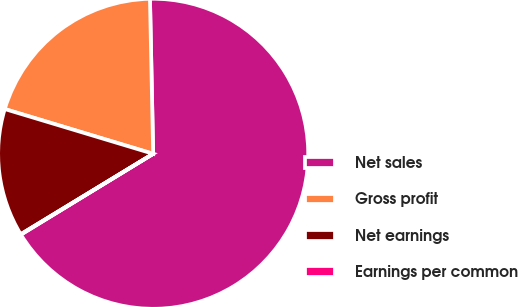Convert chart to OTSL. <chart><loc_0><loc_0><loc_500><loc_500><pie_chart><fcel>Net sales<fcel>Gross profit<fcel>Net earnings<fcel>Earnings per common<nl><fcel>66.6%<fcel>20.01%<fcel>13.35%<fcel>0.04%<nl></chart> 